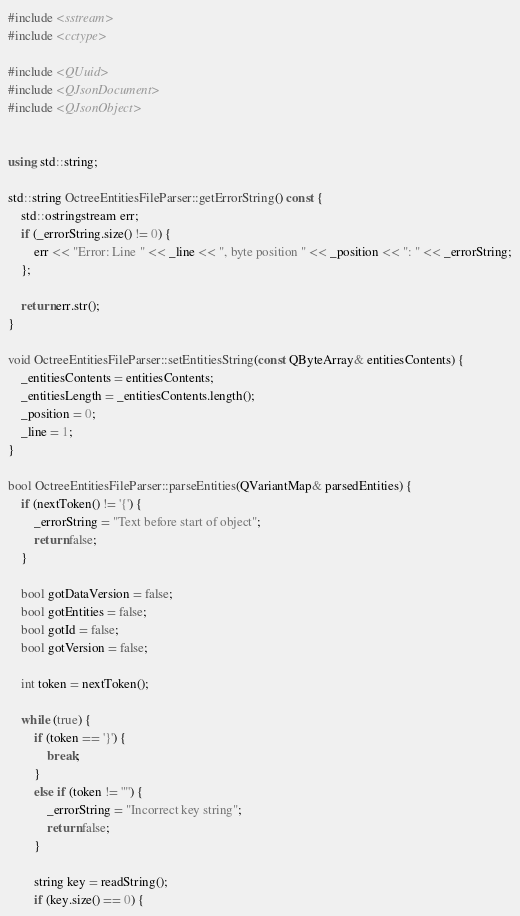<code> <loc_0><loc_0><loc_500><loc_500><_C++_>
#include <sstream>
#include <cctype>

#include <QUuid>
#include <QJsonDocument>
#include <QJsonObject>


using std::string;

std::string OctreeEntitiesFileParser::getErrorString() const {
    std::ostringstream err;
    if (_errorString.size() != 0) {
        err << "Error: Line " << _line << ", byte position " << _position << ": " << _errorString;
    };

    return err.str();
}

void OctreeEntitiesFileParser::setEntitiesString(const QByteArray& entitiesContents) {
    _entitiesContents = entitiesContents;
    _entitiesLength = _entitiesContents.length();
    _position = 0;
    _line = 1;
}

bool OctreeEntitiesFileParser::parseEntities(QVariantMap& parsedEntities) {
    if (nextToken() != '{') {
        _errorString = "Text before start of object";
        return false;
    }

    bool gotDataVersion = false;
    bool gotEntities = false;
    bool gotId = false;
    bool gotVersion = false;

    int token = nextToken();

    while (true) {
        if (token == '}') {
            break;
        }
        else if (token != '"') {
            _errorString = "Incorrect key string";
            return false;
        }

        string key = readString();
        if (key.size() == 0) {</code> 